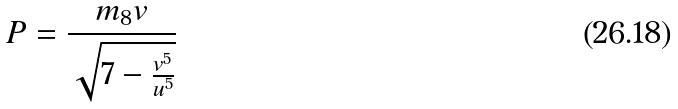<formula> <loc_0><loc_0><loc_500><loc_500>P = \frac { m _ { 8 } v } { \sqrt { 7 - \frac { v ^ { 5 } } { u ^ { 5 } } } }</formula> 